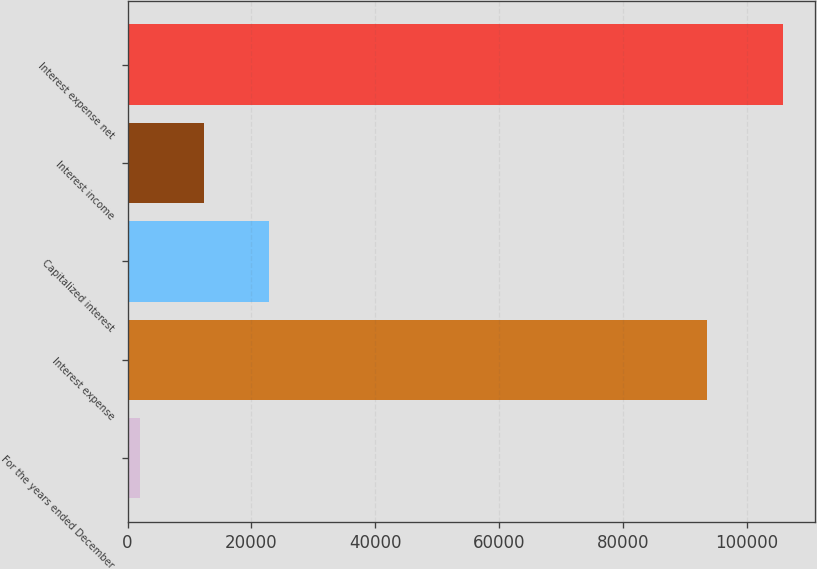Convert chart to OTSL. <chart><loc_0><loc_0><loc_500><loc_500><bar_chart><fcel>For the years ended December<fcel>Interest expense<fcel>Capitalized interest<fcel>Interest income<fcel>Interest expense net<nl><fcel>2015<fcel>93520<fcel>22766.6<fcel>12390.8<fcel>105773<nl></chart> 